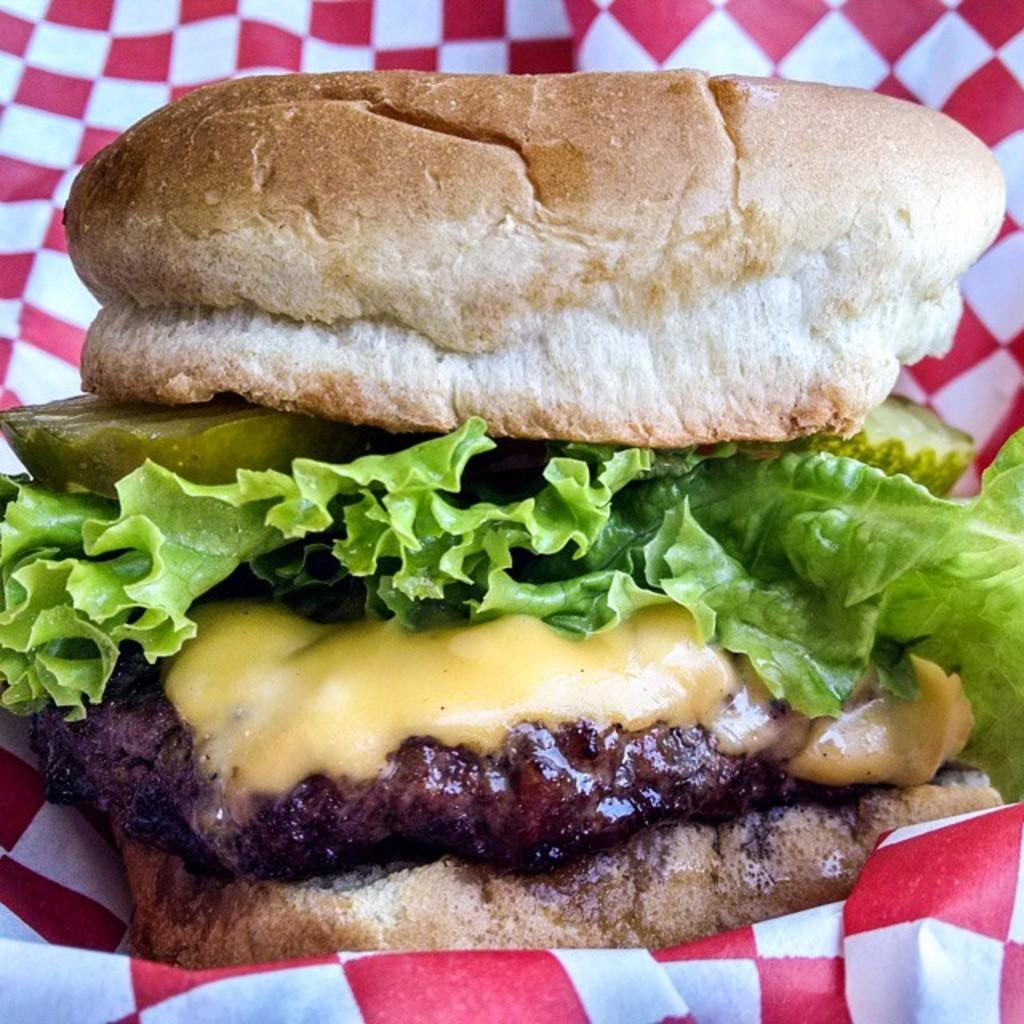What type of food is in the image? There is a burger in the image. What is the burger placed on? The burger is on a cloth. What colors are present on the cloth? The cloth is colored red and white. How many cracks can be seen on the burger in the image? There are no cracks visible on the burger in the image. What type of cart is present in the image? There is no cart present in the image. 